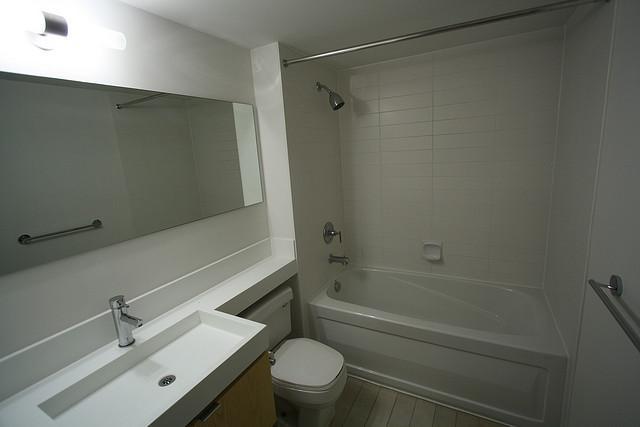How many sinks are there?
Give a very brief answer. 1. 